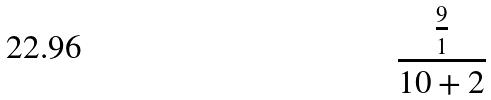<formula> <loc_0><loc_0><loc_500><loc_500>\frac { \frac { 9 } { 1 } } { 1 0 + 2 }</formula> 